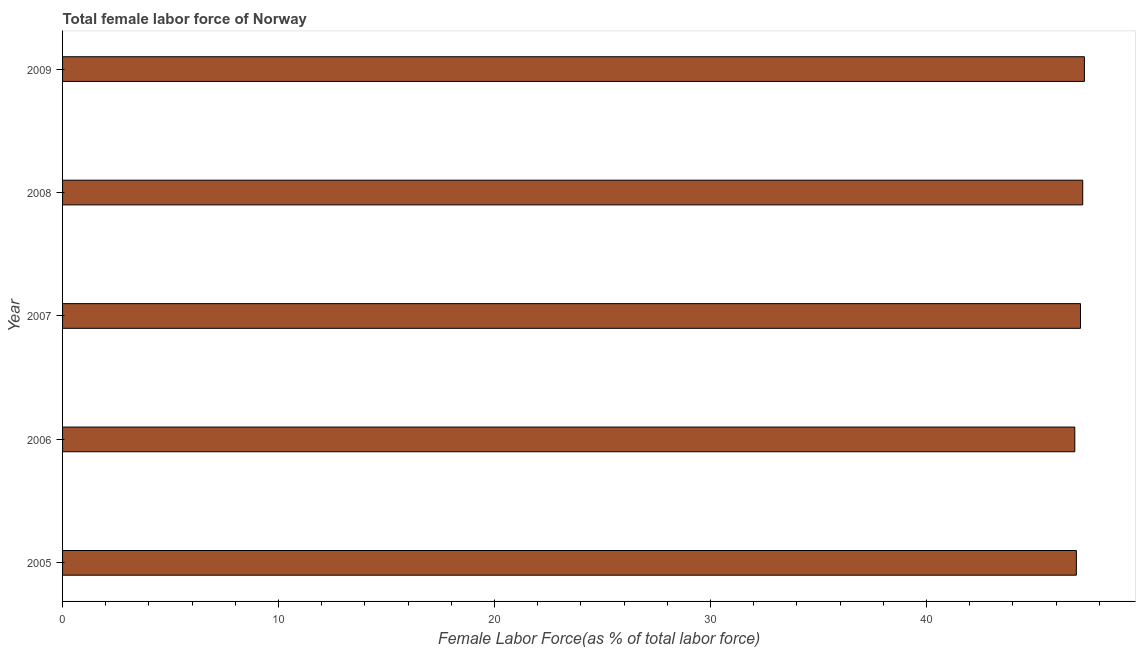Does the graph contain any zero values?
Make the answer very short. No. What is the title of the graph?
Ensure brevity in your answer.  Total female labor force of Norway. What is the label or title of the X-axis?
Provide a short and direct response. Female Labor Force(as % of total labor force). What is the label or title of the Y-axis?
Give a very brief answer. Year. What is the total female labor force in 2005?
Give a very brief answer. 46.94. Across all years, what is the maximum total female labor force?
Offer a terse response. 47.31. Across all years, what is the minimum total female labor force?
Your response must be concise. 46.87. In which year was the total female labor force minimum?
Make the answer very short. 2006. What is the sum of the total female labor force?
Keep it short and to the point. 235.48. What is the difference between the total female labor force in 2005 and 2007?
Offer a terse response. -0.19. What is the average total female labor force per year?
Make the answer very short. 47.1. What is the median total female labor force?
Your response must be concise. 47.13. Is the total female labor force in 2006 less than that in 2009?
Your answer should be compact. Yes. Is the difference between the total female labor force in 2006 and 2008 greater than the difference between any two years?
Provide a short and direct response. No. What is the difference between the highest and the second highest total female labor force?
Your answer should be very brief. 0.08. What is the difference between the highest and the lowest total female labor force?
Your answer should be compact. 0.44. In how many years, is the total female labor force greater than the average total female labor force taken over all years?
Keep it short and to the point. 3. How many bars are there?
Your response must be concise. 5. How many years are there in the graph?
Keep it short and to the point. 5. What is the Female Labor Force(as % of total labor force) of 2005?
Your response must be concise. 46.94. What is the Female Labor Force(as % of total labor force) in 2006?
Offer a very short reply. 46.87. What is the Female Labor Force(as % of total labor force) of 2007?
Offer a terse response. 47.13. What is the Female Labor Force(as % of total labor force) of 2008?
Keep it short and to the point. 47.23. What is the Female Labor Force(as % of total labor force) of 2009?
Keep it short and to the point. 47.31. What is the difference between the Female Labor Force(as % of total labor force) in 2005 and 2006?
Provide a short and direct response. 0.07. What is the difference between the Female Labor Force(as % of total labor force) in 2005 and 2007?
Keep it short and to the point. -0.19. What is the difference between the Female Labor Force(as % of total labor force) in 2005 and 2008?
Offer a very short reply. -0.3. What is the difference between the Female Labor Force(as % of total labor force) in 2005 and 2009?
Provide a short and direct response. -0.37. What is the difference between the Female Labor Force(as % of total labor force) in 2006 and 2007?
Your response must be concise. -0.26. What is the difference between the Female Labor Force(as % of total labor force) in 2006 and 2008?
Offer a terse response. -0.37. What is the difference between the Female Labor Force(as % of total labor force) in 2006 and 2009?
Provide a short and direct response. -0.44. What is the difference between the Female Labor Force(as % of total labor force) in 2007 and 2008?
Keep it short and to the point. -0.1. What is the difference between the Female Labor Force(as % of total labor force) in 2007 and 2009?
Your answer should be very brief. -0.18. What is the difference between the Female Labor Force(as % of total labor force) in 2008 and 2009?
Provide a succinct answer. -0.08. What is the ratio of the Female Labor Force(as % of total labor force) in 2005 to that in 2006?
Provide a succinct answer. 1. What is the ratio of the Female Labor Force(as % of total labor force) in 2005 to that in 2009?
Give a very brief answer. 0.99. What is the ratio of the Female Labor Force(as % of total labor force) in 2006 to that in 2008?
Your answer should be very brief. 0.99. What is the ratio of the Female Labor Force(as % of total labor force) in 2007 to that in 2009?
Your response must be concise. 1. 